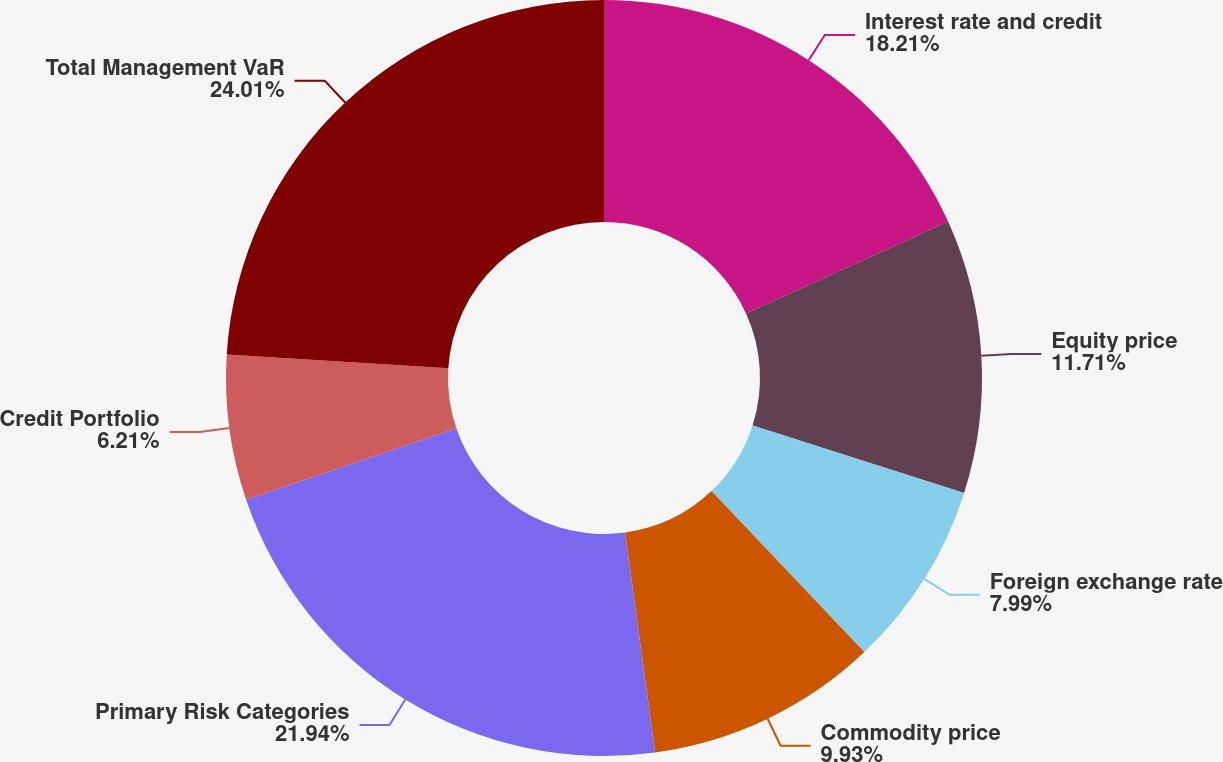Convert chart. <chart><loc_0><loc_0><loc_500><loc_500><pie_chart><fcel>Interest rate and credit<fcel>Equity price<fcel>Foreign exchange rate<fcel>Commodity price<fcel>Primary Risk Categories<fcel>Credit Portfolio<fcel>Total Management VaR<nl><fcel>18.21%<fcel>11.71%<fcel>7.99%<fcel>9.93%<fcel>21.94%<fcel>6.21%<fcel>24.01%<nl></chart> 